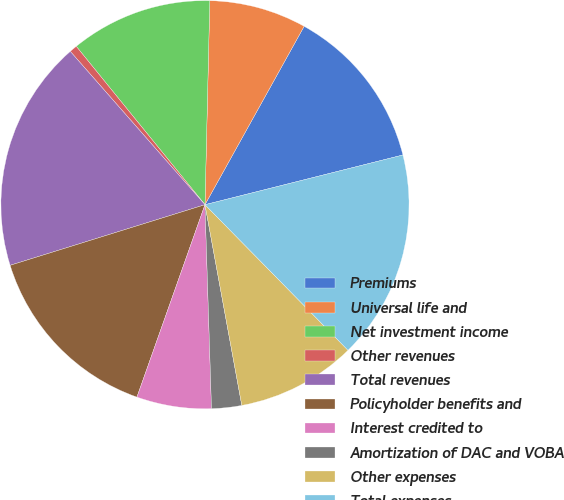<chart> <loc_0><loc_0><loc_500><loc_500><pie_chart><fcel>Premiums<fcel>Universal life and<fcel>Net investment income<fcel>Other revenues<fcel>Total revenues<fcel>Policyholder benefits and<fcel>Interest credited to<fcel>Amortization of DAC and VOBA<fcel>Other expenses<fcel>Total expenses<nl><fcel>13.01%<fcel>7.7%<fcel>11.24%<fcel>0.61%<fcel>18.33%<fcel>14.79%<fcel>5.92%<fcel>2.38%<fcel>9.47%<fcel>16.56%<nl></chart> 